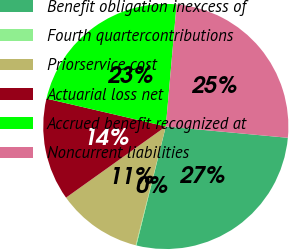Convert chart to OTSL. <chart><loc_0><loc_0><loc_500><loc_500><pie_chart><fcel>Benefit obligation inexcess of<fcel>Fourth quartercontributions<fcel>Priorservice cost<fcel>Actuarial loss net<fcel>Accrued benefit recognized at<fcel>Noncurrent liabilities<nl><fcel>27.39%<fcel>0.09%<fcel>11.19%<fcel>13.51%<fcel>22.75%<fcel>25.07%<nl></chart> 